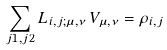Convert formula to latex. <formula><loc_0><loc_0><loc_500><loc_500>\sum _ { j 1 , j 2 } L _ { i , j ; \mu , \nu } \, V _ { \mu , \nu } = \rho _ { i , j }</formula> 